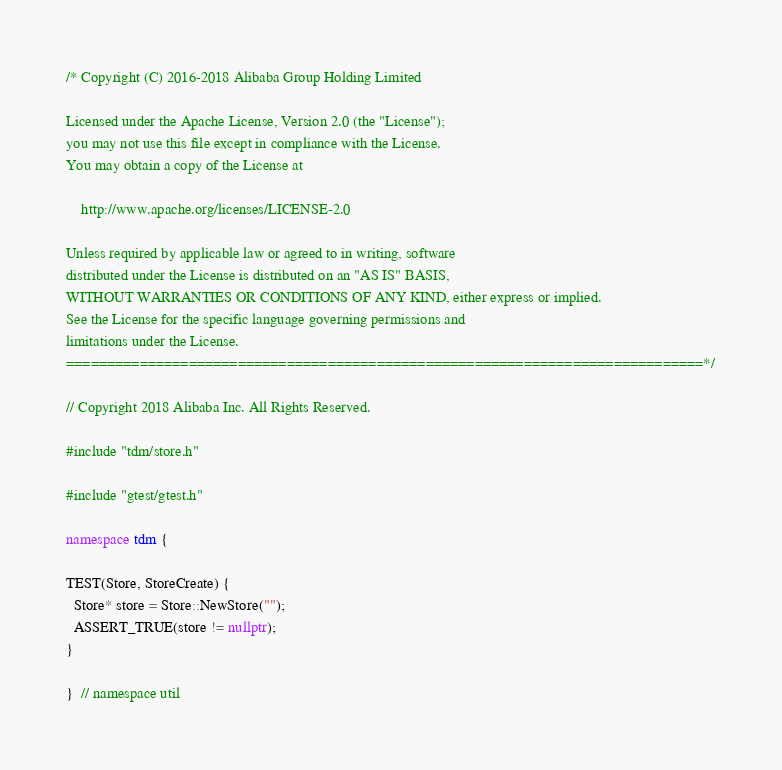Convert code to text. <code><loc_0><loc_0><loc_500><loc_500><_C++_>/* Copyright (C) 2016-2018 Alibaba Group Holding Limited

Licensed under the Apache License, Version 2.0 (the "License");
you may not use this file except in compliance with the License.
You may obtain a copy of the License at

    http://www.apache.org/licenses/LICENSE-2.0

Unless required by applicable law or agreed to in writing, software
distributed under the License is distributed on an "AS IS" BASIS,
WITHOUT WARRANTIES OR CONDITIONS OF ANY KIND, either express or implied.
See the License for the specific language governing permissions and
limitations under the License.
==============================================================================*/

// Copyright 2018 Alibaba Inc. All Rights Reserved.

#include "tdm/store.h"

#include "gtest/gtest.h"

namespace tdm {

TEST(Store, StoreCreate) {
  Store* store = Store::NewStore("");
  ASSERT_TRUE(store != nullptr);
}

}  // namespace util
</code> 